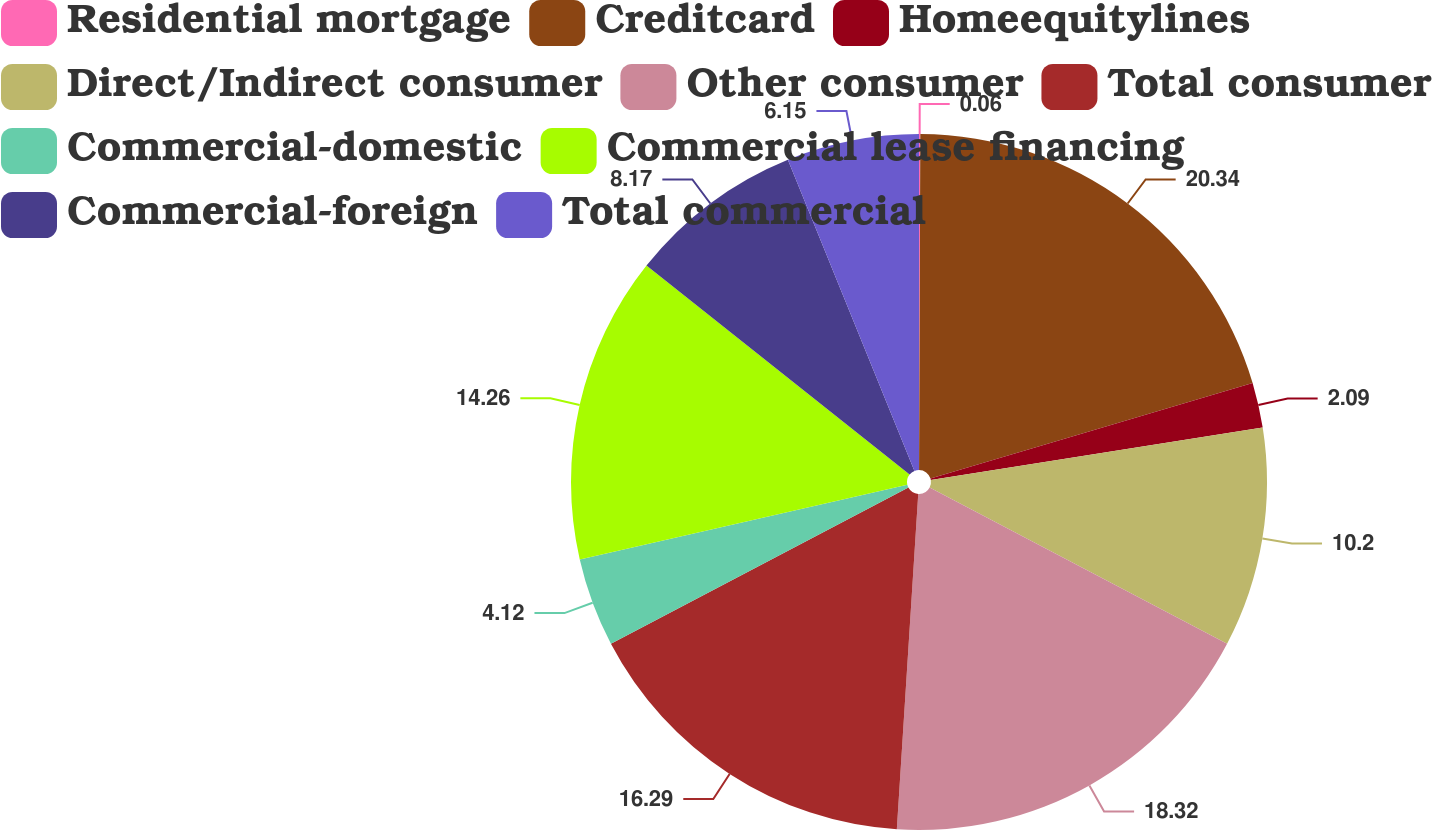Convert chart to OTSL. <chart><loc_0><loc_0><loc_500><loc_500><pie_chart><fcel>Residential mortgage<fcel>Creditcard<fcel>Homeequitylines<fcel>Direct/Indirect consumer<fcel>Other consumer<fcel>Total consumer<fcel>Commercial-domestic<fcel>Commercial lease financing<fcel>Commercial-foreign<fcel>Total commercial<nl><fcel>0.06%<fcel>20.35%<fcel>2.09%<fcel>10.2%<fcel>18.32%<fcel>16.29%<fcel>4.12%<fcel>14.26%<fcel>8.17%<fcel>6.15%<nl></chart> 